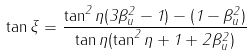Convert formula to latex. <formula><loc_0><loc_0><loc_500><loc_500>\tan \xi = \frac { \tan ^ { 2 } \eta ( 3 \beta _ { u } ^ { 2 } - 1 ) - ( 1 - \beta _ { u } ^ { 2 } ) } { \tan \eta ( \tan ^ { 2 } \eta + 1 + 2 \beta _ { u } ^ { 2 } ) }</formula> 